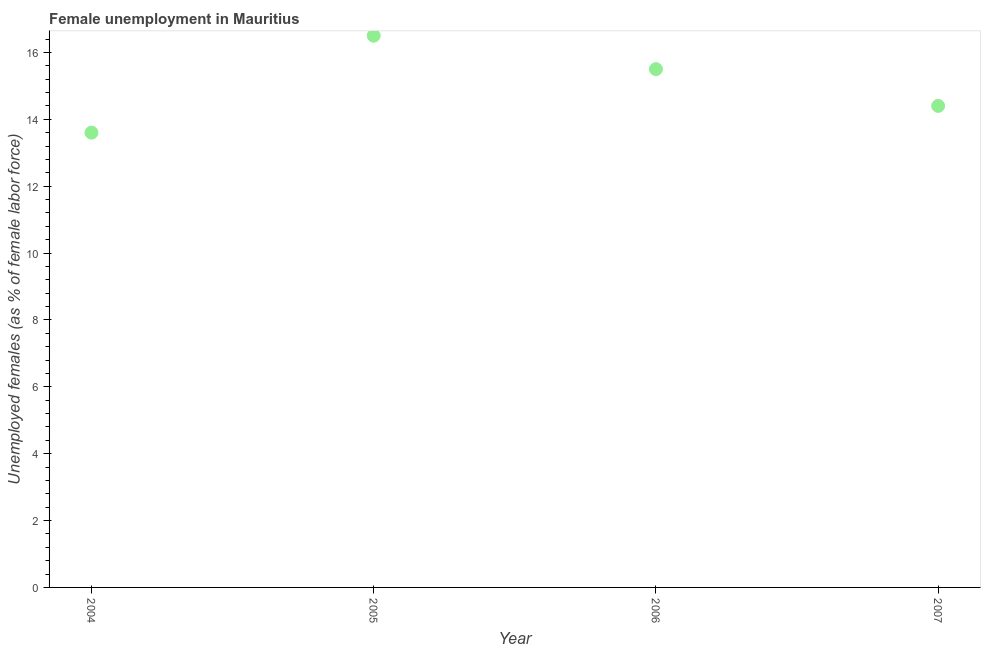What is the unemployed females population in 2005?
Keep it short and to the point. 16.5. Across all years, what is the minimum unemployed females population?
Make the answer very short. 13.6. What is the difference between the unemployed females population in 2006 and 2007?
Your answer should be very brief. 1.1. What is the average unemployed females population per year?
Your answer should be compact. 15. What is the median unemployed females population?
Keep it short and to the point. 14.95. What is the ratio of the unemployed females population in 2005 to that in 2007?
Make the answer very short. 1.15. Is the unemployed females population in 2004 less than that in 2006?
Your response must be concise. Yes. Is the difference between the unemployed females population in 2005 and 2007 greater than the difference between any two years?
Give a very brief answer. No. What is the difference between the highest and the second highest unemployed females population?
Keep it short and to the point. 1. Is the sum of the unemployed females population in 2004 and 2006 greater than the maximum unemployed females population across all years?
Offer a very short reply. Yes. What is the difference between the highest and the lowest unemployed females population?
Your answer should be very brief. 2.9. How many years are there in the graph?
Make the answer very short. 4. What is the difference between two consecutive major ticks on the Y-axis?
Your answer should be compact. 2. What is the title of the graph?
Offer a terse response. Female unemployment in Mauritius. What is the label or title of the X-axis?
Your answer should be very brief. Year. What is the label or title of the Y-axis?
Provide a short and direct response. Unemployed females (as % of female labor force). What is the Unemployed females (as % of female labor force) in 2004?
Offer a terse response. 13.6. What is the Unemployed females (as % of female labor force) in 2007?
Provide a succinct answer. 14.4. What is the difference between the Unemployed females (as % of female labor force) in 2004 and 2005?
Provide a short and direct response. -2.9. What is the difference between the Unemployed females (as % of female labor force) in 2004 and 2007?
Keep it short and to the point. -0.8. What is the difference between the Unemployed females (as % of female labor force) in 2006 and 2007?
Make the answer very short. 1.1. What is the ratio of the Unemployed females (as % of female labor force) in 2004 to that in 2005?
Your answer should be very brief. 0.82. What is the ratio of the Unemployed females (as % of female labor force) in 2004 to that in 2006?
Make the answer very short. 0.88. What is the ratio of the Unemployed females (as % of female labor force) in 2004 to that in 2007?
Your answer should be very brief. 0.94. What is the ratio of the Unemployed females (as % of female labor force) in 2005 to that in 2006?
Offer a terse response. 1.06. What is the ratio of the Unemployed females (as % of female labor force) in 2005 to that in 2007?
Ensure brevity in your answer.  1.15. What is the ratio of the Unemployed females (as % of female labor force) in 2006 to that in 2007?
Your response must be concise. 1.08. 